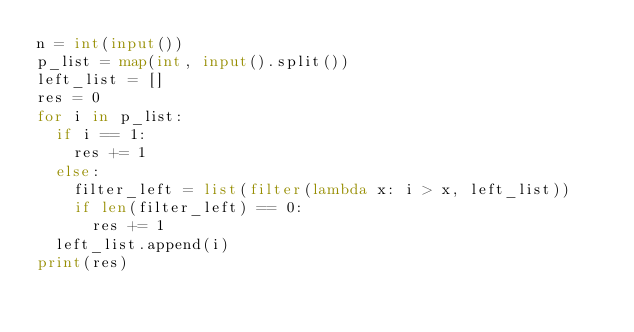<code> <loc_0><loc_0><loc_500><loc_500><_Python_>n = int(input())
p_list = map(int, input().split())
left_list = []
res = 0
for i in p_list:
  if i == 1:
    res += 1
  else:
    filter_left = list(filter(lambda x: i > x, left_list))
    if len(filter_left) == 0:
      res += 1
  left_list.append(i)
print(res)</code> 